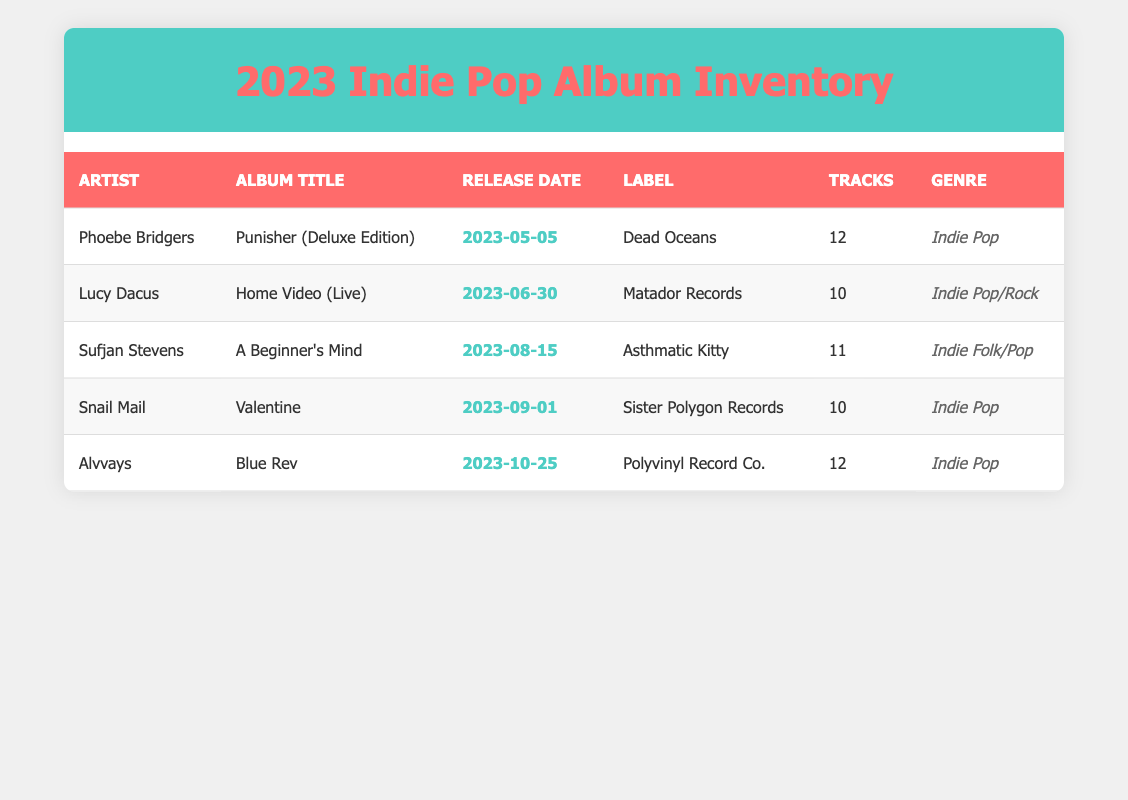What is the release date of Phoebe Bridgers' album? The release date for Phoebe Bridgers' album "Punisher (Deluxe Edition)" is listed in the table under the "Release Date" column. Referring to that row, it shows "2023-05-05".
Answer: 2023-05-05 How many tracks are on Lucy Dacus' album? The number of tracks for Lucy Dacus' album "Home Video (Live)" can be found in the "Tracks" column corresponding to her row. It states that there are "10" tracks on the album.
Answer: 10 Which artist has the latest album release date? To determine the artist with the latest album release date, we look at the "Release Date" column for all entries and identify the most recent one. Alvvays' album "Blue Rev" has the latest release date of "2023-10-25".
Answer: Alvvays Is Sufjan Stevens' album categorized under Indie Pop? To answer this, we check the "Genre" column for Sufjan Stevens' album "A Beginner's Mind". The genre listed is "Indie Folk/Pop", which is not the same as Indie Pop. Thus, the answer is no.
Answer: No What is the average number of tracks across all albums listed? First, we add the number of tracks from each album: 12 (Phoebe Bridgers) + 10 (Lucy Dacus) + 11 (Sufjan Stevens) + 10 (Snail Mail) + 12 (Alvvays) = 65. Then, we divide this total by the number of albums, which is 5: 65 / 5 = 13. Therefore, the average number of tracks across all albums is 13.
Answer: 13 Which label released the album "Valentine"? The label for the album "Valentine" by Snail Mail can be found in the corresponding row under the "Label" column. It indicates that the album was released under "Sister Polygon Records".
Answer: Sister Polygon Records How many artists have albums categorized solely as Indie Pop? We need to count the artists whose albums are categorized under "Indie Pop" in the "Genre" column. From the table, Phoebe Bridgers, Snail Mail, and Alvvays fall into this category, giving us a total of 3 artists.
Answer: 3 What are the titles of the albums released by artists in 2023? To list the album titles, we refer to the "Album Title" column for all five artists and extract their titles: "Punisher (Deluxe Edition)", "Home Video (Live)", "A Beginner's Mind", "Valentine", and "Blue Rev".
Answer: Punisher (Deluxe Edition), Home Video (Live), A Beginner's Mind, Valentine, Blue Rev 